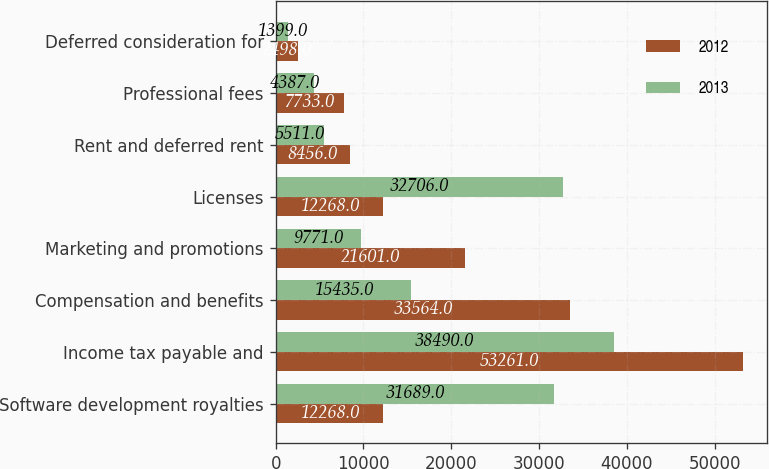Convert chart. <chart><loc_0><loc_0><loc_500><loc_500><stacked_bar_chart><ecel><fcel>Software development royalties<fcel>Income tax payable and<fcel>Compensation and benefits<fcel>Marketing and promotions<fcel>Licenses<fcel>Rent and deferred rent<fcel>Professional fees<fcel>Deferred consideration for<nl><fcel>2012<fcel>12268<fcel>53261<fcel>33564<fcel>21601<fcel>12268<fcel>8456<fcel>7733<fcel>2498<nl><fcel>2013<fcel>31689<fcel>38490<fcel>15435<fcel>9771<fcel>32706<fcel>5511<fcel>4387<fcel>1399<nl></chart> 